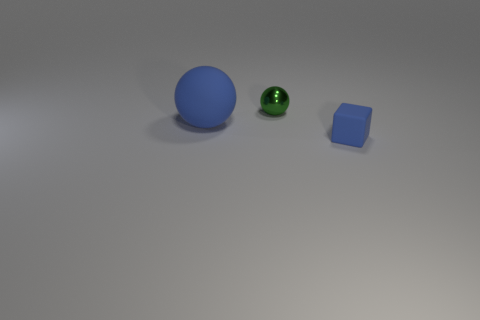Add 2 metal balls. How many objects exist? 5 Subtract all spheres. How many objects are left? 1 Add 3 tiny red cubes. How many tiny red cubes exist? 3 Subtract 1 blue cubes. How many objects are left? 2 Subtract all big balls. Subtract all tiny matte blocks. How many objects are left? 1 Add 3 blue rubber blocks. How many blue rubber blocks are left? 4 